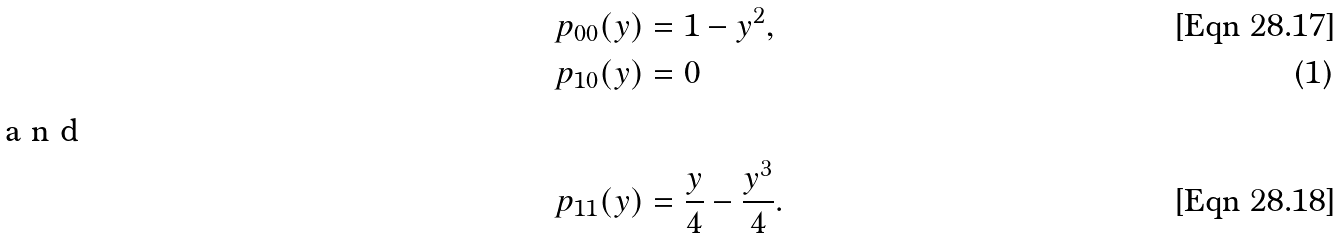<formula> <loc_0><loc_0><loc_500><loc_500>p _ { 0 0 } ( y ) & = 1 - y ^ { 2 } , \\ p _ { 1 0 } ( y ) & = 0 \intertext { a n d } p _ { 1 1 } ( y ) & = \frac { y } 4 - \frac { y ^ { 3 } } 4 .</formula> 